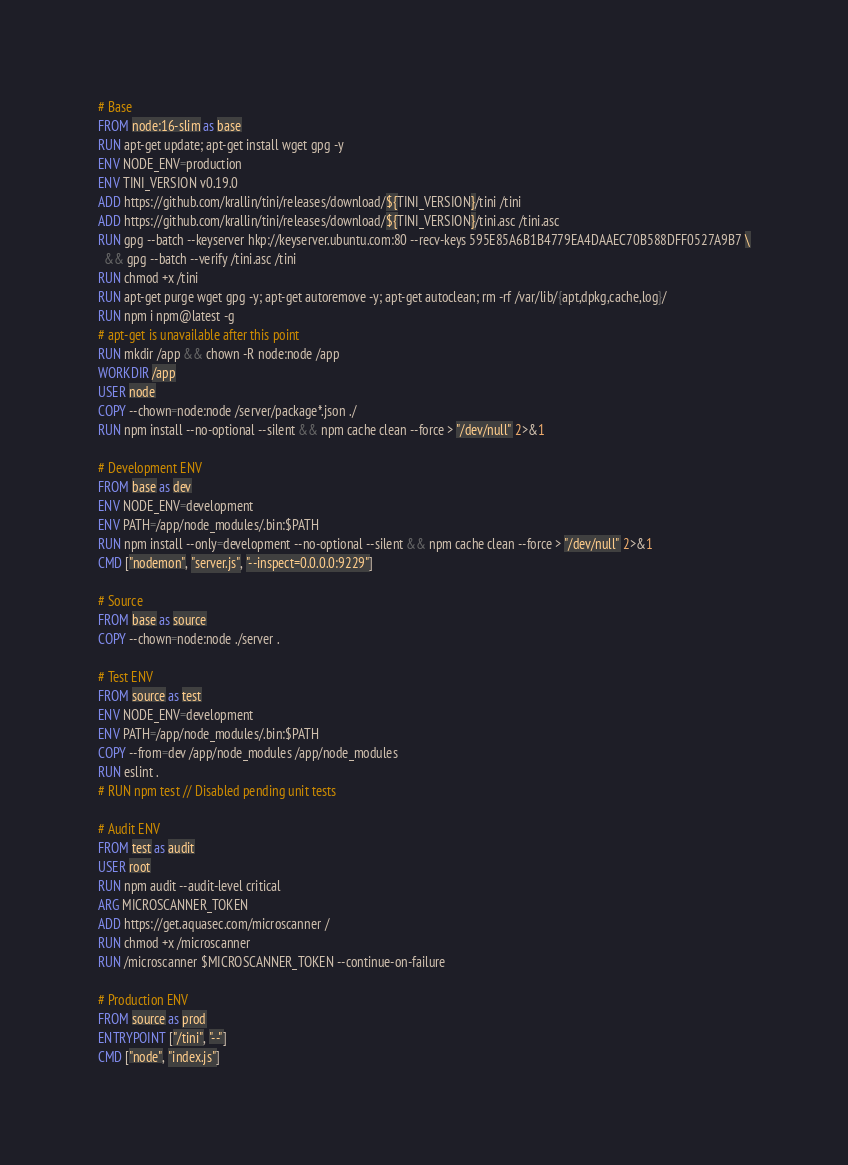Convert code to text. <code><loc_0><loc_0><loc_500><loc_500><_Dockerfile_># Base
FROM node:16-slim as base
RUN apt-get update; apt-get install wget gpg -y
ENV NODE_ENV=production
ENV TINI_VERSION v0.19.0
ADD https://github.com/krallin/tini/releases/download/${TINI_VERSION}/tini /tini
ADD https://github.com/krallin/tini/releases/download/${TINI_VERSION}/tini.asc /tini.asc
RUN gpg --batch --keyserver hkp://keyserver.ubuntu.com:80 --recv-keys 595E85A6B1B4779EA4DAAEC70B588DFF0527A9B7 \
  && gpg --batch --verify /tini.asc /tini
RUN chmod +x /tini
RUN apt-get purge wget gpg -y; apt-get autoremove -y; apt-get autoclean; rm -rf /var/lib/{apt,dpkg,cache,log}/
RUN npm i npm@latest -g
# apt-get is unavailable after this point
RUN mkdir /app && chown -R node:node /app
WORKDIR /app
USER node
COPY --chown=node:node /server/package*.json ./
RUN npm install --no-optional --silent && npm cache clean --force > "/dev/null" 2>&1

# Development ENV
FROM base as dev
ENV NODE_ENV=development
ENV PATH=/app/node_modules/.bin:$PATH
RUN npm install --only=development --no-optional --silent && npm cache clean --force > "/dev/null" 2>&1
CMD ["nodemon", "server.js", "--inspect=0.0.0.0:9229"]

# Source
FROM base as source
COPY --chown=node:node ./server .

# Test ENV
FROM source as test
ENV NODE_ENV=development
ENV PATH=/app/node_modules/.bin:$PATH
COPY --from=dev /app/node_modules /app/node_modules
RUN eslint .
# RUN npm test // Disabled pending unit tests

# Audit ENV
FROM test as audit
USER root
RUN npm audit --audit-level critical
ARG MICROSCANNER_TOKEN
ADD https://get.aquasec.com/microscanner /
RUN chmod +x /microscanner
RUN /microscanner $MICROSCANNER_TOKEN --continue-on-failure

# Production ENV
FROM source as prod
ENTRYPOINT ["/tini", "--"]
CMD ["node", "index.js"]</code> 